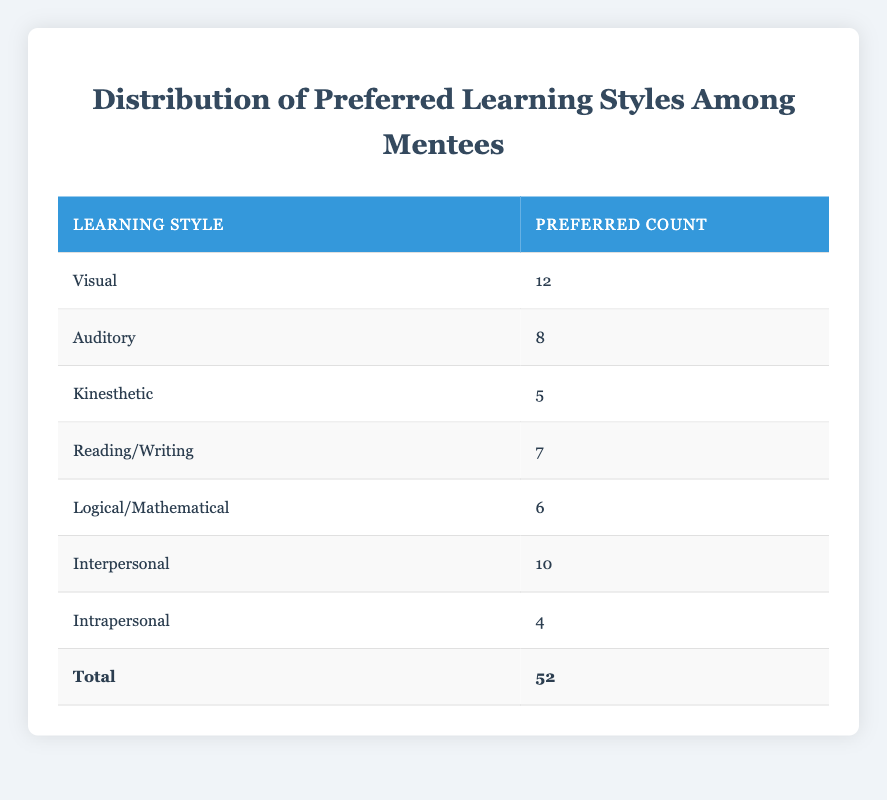What is the preferred count for the Visual learning style? The table shows that the preferred count for the Visual learning style is listed directly in the respective row under the "Preferred Count" column.
Answer: 12 How many mentees prefer the Auditory learning style? The data in the table indicates the preferred count of mentees who favor the Auditory style, which is found in the corresponding row.
Answer: 8 What is the total number of preferred learning styles counted? To find the total, we can add up all the preferred counts in the "Preferred Count" column: 12 (Visual) + 8 (Auditory) + 5 (Kinesthetic) + 7 (Reading/Writing) + 6 (Logical/Mathematical) + 10 (Interpersonal) + 4 (Intrapersonal) = 52. The "Total" row confirms this sum.
Answer: 52 Which learning style has the least preferred count? By examining the "Preferred Count" column, we look for the smallest number listed. The Intrapersonal style has the lowest count of 4.
Answer: Intrapersonal What is the difference in preferred count between the Visual and Intrapersonal learning styles? We first identify the counts for both styles: Visual has 12 and Intrapersonal has 4. The difference is calculated by subtracting the Intrapersonal count from the Visual count: 12 - 4 = 8.
Answer: 8 Is the preferred count for Kinesthetic learning style greater than those for Reading/Writing and Logical/Mathematical styles combined? The Kinesthetic count is 5. Reading/Writing has 7 and Logical/Mathematical has 6; combined they equal 7 + 6 = 13. Since 5 is not greater than 13, the statement is false.
Answer: No How many more mentees prefer the Interpersonal learning style compared to the Kinesthetic learning style? We check the counts: Interpersonal has 10 and Kinesthetic has 5. The difference is calculated as 10 - 5 = 5, indicating there are 5 more mentees who prefer Interpersonal.
Answer: 5 Which two learning styles combined have the highest preferred count? Analyzing the counts, the Visual (12) and Interpersonal (10) styles are the largest. Their combined count is 12 + 10 = 22, making them the highest together.
Answer: Visual and Interpersonal What is the average preferred count across all learning styles? We know the total count of preferred styles is 52, and there are 7 different styles. The average is calculated by dividing the total count by the number of styles: 52 / 7 ≈ 7.43.
Answer: Approximately 7.43 